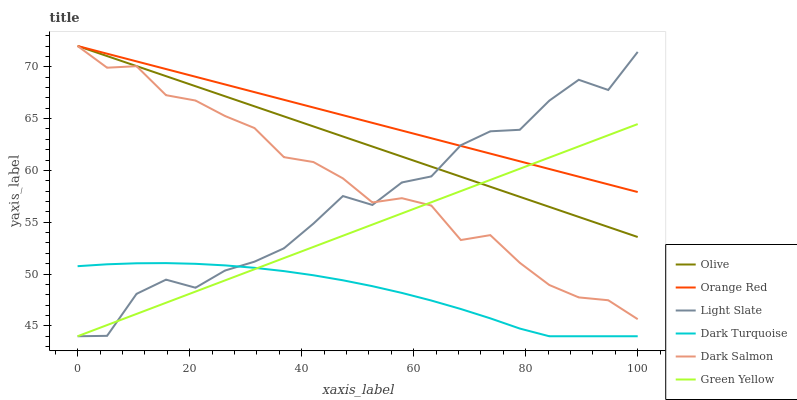Does Dark Turquoise have the minimum area under the curve?
Answer yes or no. Yes. Does Orange Red have the maximum area under the curve?
Answer yes or no. Yes. Does Dark Salmon have the minimum area under the curve?
Answer yes or no. No. Does Dark Salmon have the maximum area under the curve?
Answer yes or no. No. Is Green Yellow the smoothest?
Answer yes or no. Yes. Is Light Slate the roughest?
Answer yes or no. Yes. Is Dark Turquoise the smoothest?
Answer yes or no. No. Is Dark Turquoise the roughest?
Answer yes or no. No. Does Light Slate have the lowest value?
Answer yes or no. Yes. Does Dark Salmon have the lowest value?
Answer yes or no. No. Does Orange Red have the highest value?
Answer yes or no. Yes. Does Dark Turquoise have the highest value?
Answer yes or no. No. Is Dark Turquoise less than Olive?
Answer yes or no. Yes. Is Orange Red greater than Dark Turquoise?
Answer yes or no. Yes. Does Green Yellow intersect Orange Red?
Answer yes or no. Yes. Is Green Yellow less than Orange Red?
Answer yes or no. No. Is Green Yellow greater than Orange Red?
Answer yes or no. No. Does Dark Turquoise intersect Olive?
Answer yes or no. No. 